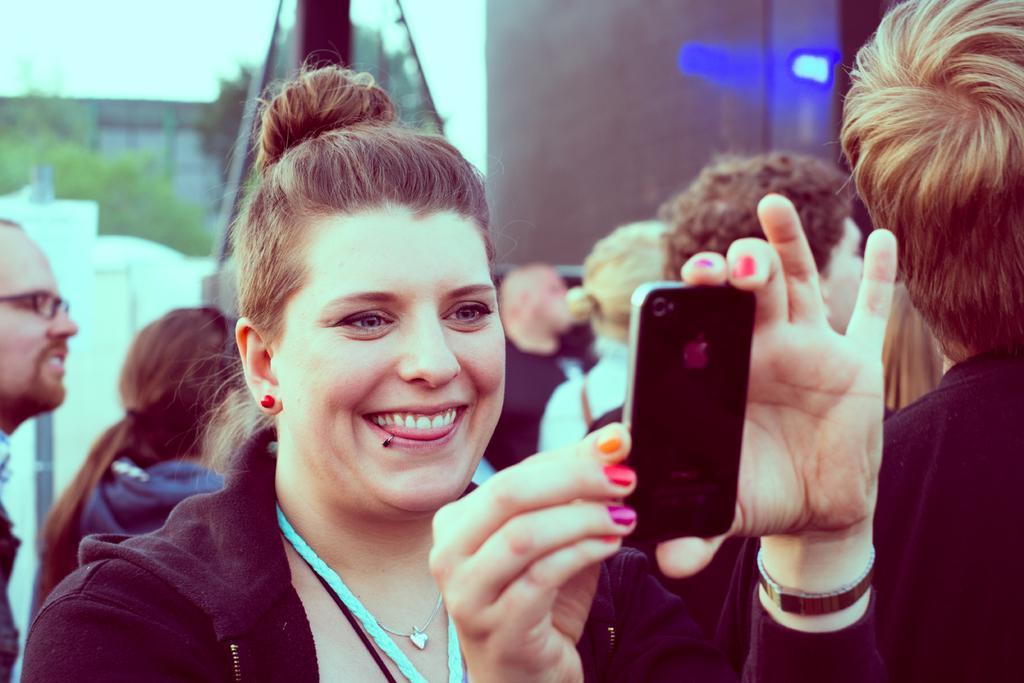How would you summarize this image in a sentence or two? in the given image we can see there are many person around. This woman is catching a device in her hand. She is wearing a black color jacket, necklace and a watch. This is a blue light emitting. The sky is in white color. There are trees. 